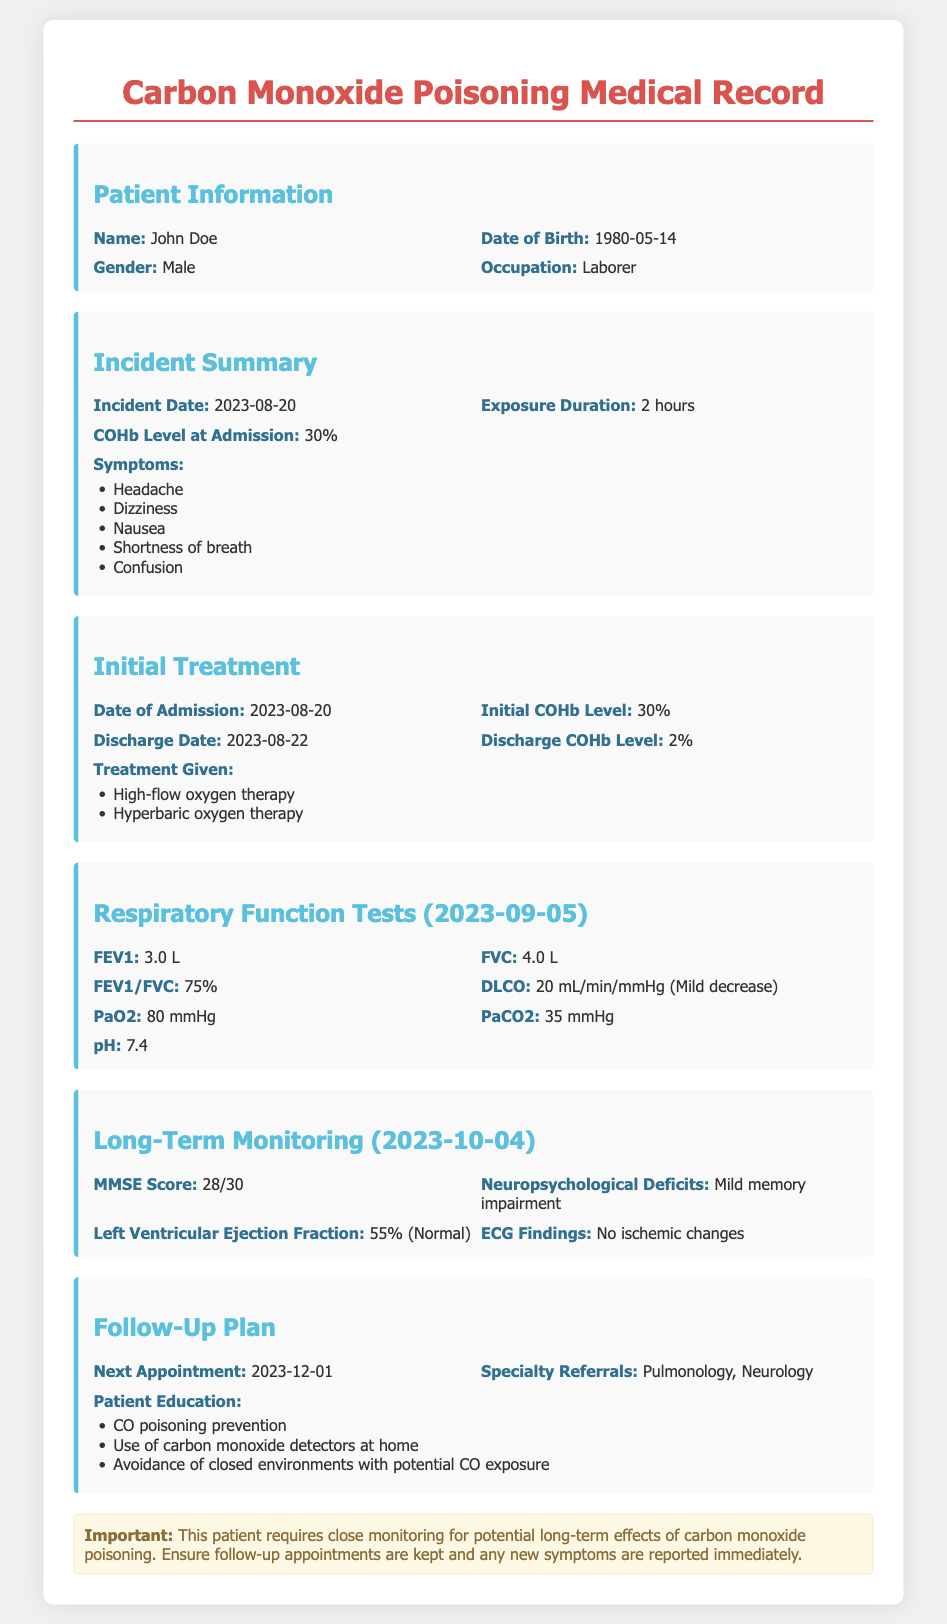What is the patient's name? The patient's name is mentioned in the "Patient Information" section of the document.
Answer: John Doe What was the COHb level at admission? The COHb level at admission is stated in the "Incident Summary" section.
Answer: 30% What is the initial COHb level? The initial COHb level is found in the "Initial Treatment" section.
Answer: 30% What is the date of the next follow-up appointment? The date of the next appointment is provided in the "Follow-Up Plan" section.
Answer: 2023-12-01 What was the patient's FEV1 value during the Respiratory Function Tests? The FEV1 value can be found in the "Respiratory Function Tests" section.
Answer: 3.0 L What type of therapy was given to the patient? The treatment given to the patient is detailed in the "Initial Treatment" section.
Answer: High-flow oxygen therapy, Hyperbaric oxygen therapy What was the patient's MMSE Score? The MMSE Score is recorded in the "Long-Term Monitoring" section of the document.
Answer: 28/30 What symptoms did the patient experience during the incident? The symptoms experienced are listed in the "Incident Summary" section.
Answer: Headache, Dizziness, Nausea, Shortness of breath, Confusion What is the patient's left ventricular ejection fraction? The left ventricular ejection fraction is reported in the "Long-Term Monitoring" section.
Answer: 55% (Normal) What referrals were made for the patient? The specialty referrals are mentioned in the "Follow-Up Plan" section.
Answer: Pulmonology, Neurology 